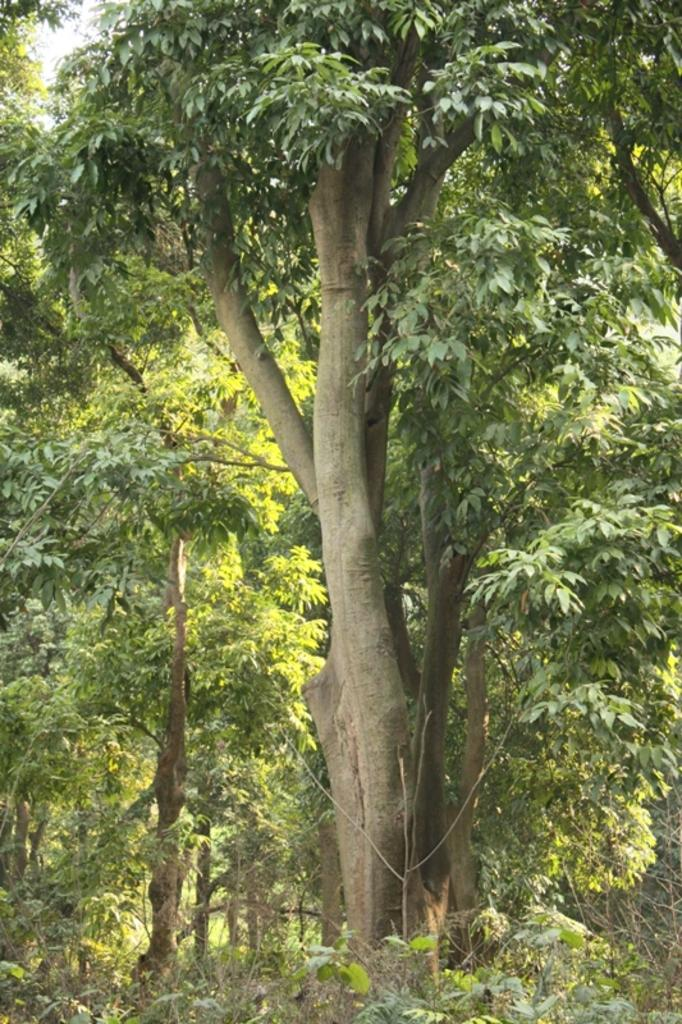What type of vegetation can be seen in the image? There are trees in the image. What features do the trees have? The trees have branches and leaves. What is the color of the leaves on the trees? The leaves are green in color. What type of meal is being prepared in the image? There is no meal preparation visible in the image; it only features trees with green leaves. How many dolls are sitting on the branches of the trees? There are no dolls present in the image; it only features trees with green leaves. 